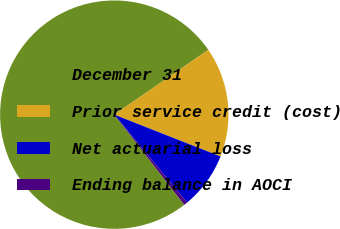<chart> <loc_0><loc_0><loc_500><loc_500><pie_chart><fcel>December 31<fcel>Prior service credit (cost)<fcel>Net actuarial loss<fcel>Ending balance in AOCI<nl><fcel>75.9%<fcel>15.57%<fcel>8.03%<fcel>0.49%<nl></chart> 